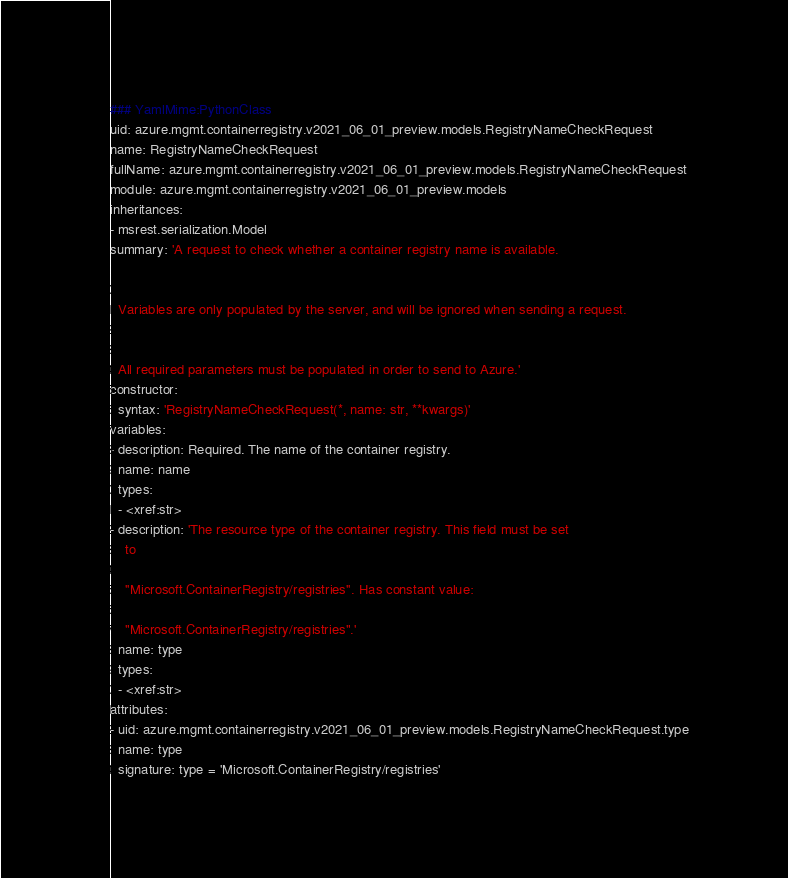Convert code to text. <code><loc_0><loc_0><loc_500><loc_500><_YAML_>### YamlMime:PythonClass
uid: azure.mgmt.containerregistry.v2021_06_01_preview.models.RegistryNameCheckRequest
name: RegistryNameCheckRequest
fullName: azure.mgmt.containerregistry.v2021_06_01_preview.models.RegistryNameCheckRequest
module: azure.mgmt.containerregistry.v2021_06_01_preview.models
inheritances:
- msrest.serialization.Model
summary: 'A request to check whether a container registry name is available.


  Variables are only populated by the server, and will be ignored when sending a request.


  All required parameters must be populated in order to send to Azure.'
constructor:
  syntax: 'RegistryNameCheckRequest(*, name: str, **kwargs)'
variables:
- description: Required. The name of the container registry.
  name: name
  types:
  - <xref:str>
- description: 'The resource type of the container registry. This field must be set
    to

    ''Microsoft.ContainerRegistry/registries''. Has constant value:

    "Microsoft.ContainerRegistry/registries".'
  name: type
  types:
  - <xref:str>
attributes:
- uid: azure.mgmt.containerregistry.v2021_06_01_preview.models.RegistryNameCheckRequest.type
  name: type
  signature: type = 'Microsoft.ContainerRegistry/registries'
</code> 